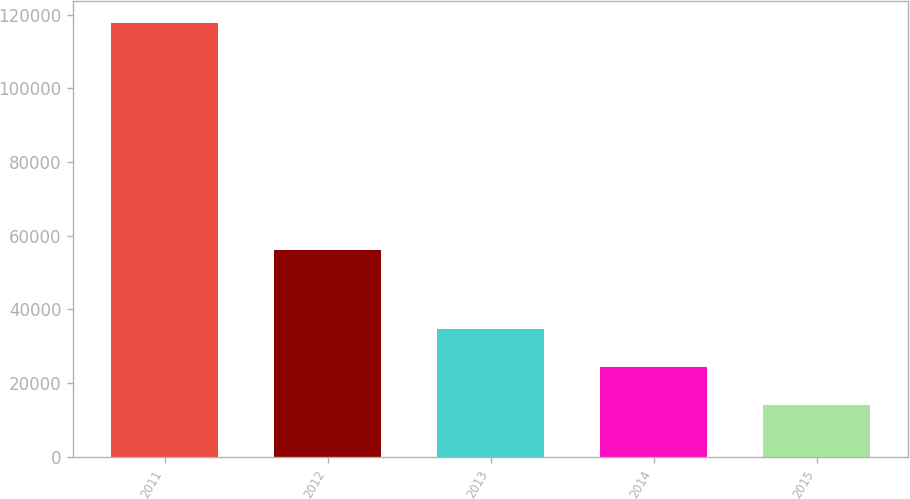<chart> <loc_0><loc_0><loc_500><loc_500><bar_chart><fcel>2011<fcel>2012<fcel>2013<fcel>2014<fcel>2015<nl><fcel>117795<fcel>56249<fcel>34740.6<fcel>24358.8<fcel>13977<nl></chart> 